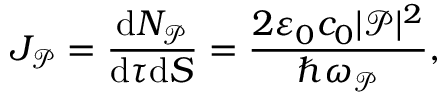Convert formula to latex. <formula><loc_0><loc_0><loc_500><loc_500>J _ { \mathcal { P } } = \frac { d N _ { \mathcal { P } } } { d \tau d S } = \frac { 2 \varepsilon _ { 0 } c _ { 0 } | \mathcal { P } | ^ { 2 } } { \hbar { \omega } _ { \mathcal { P } } } ,</formula> 